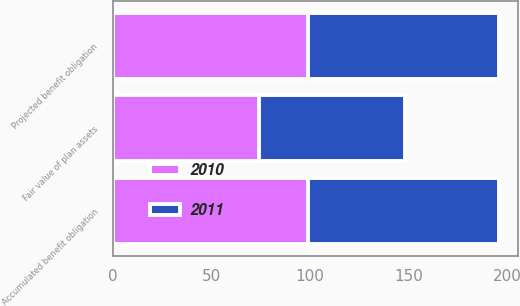<chart> <loc_0><loc_0><loc_500><loc_500><stacked_bar_chart><ecel><fcel>Projected benefit obligation<fcel>Accumulated benefit obligation<fcel>Fair value of plan assets<nl><fcel>2010<fcel>99<fcel>99<fcel>74<nl><fcel>2011<fcel>97<fcel>97<fcel>74<nl></chart> 